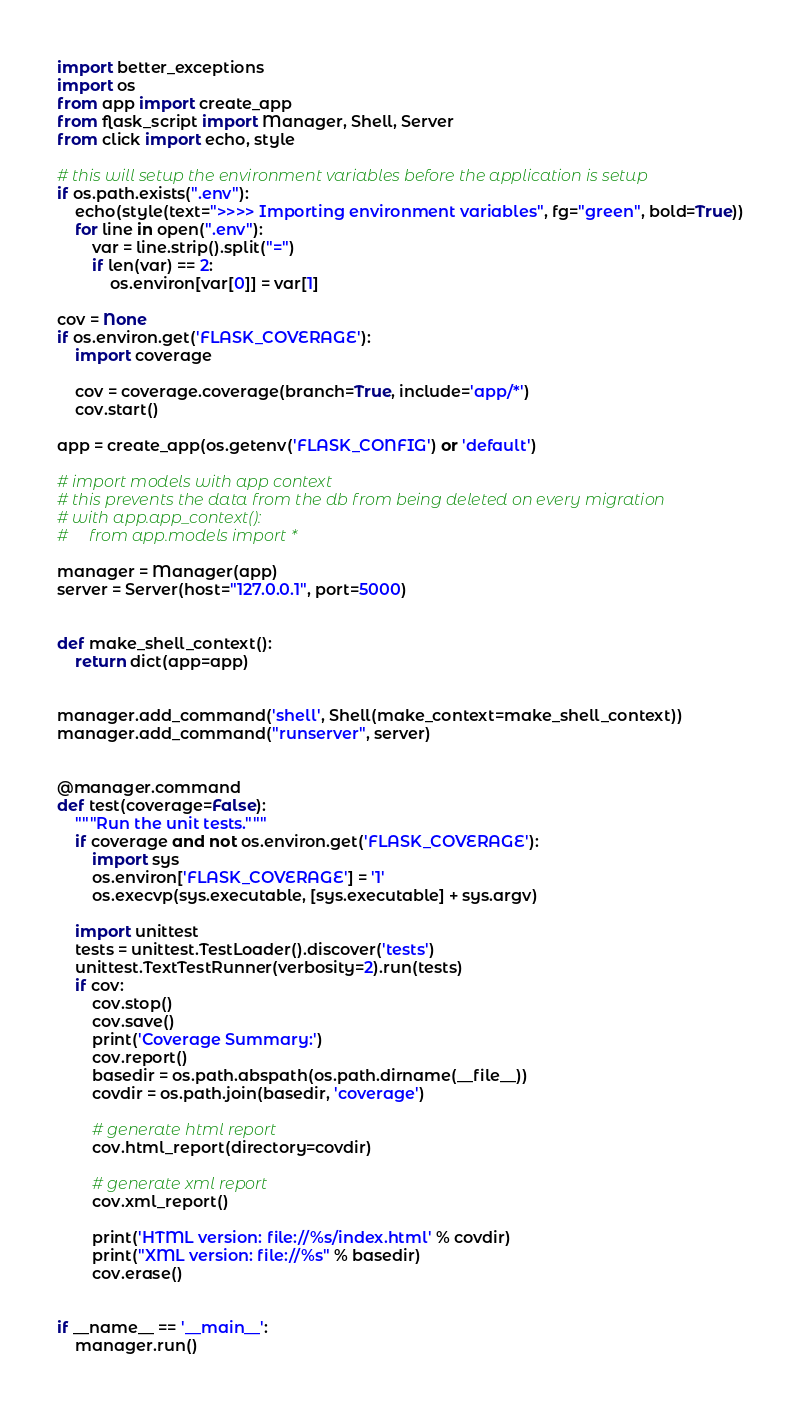<code> <loc_0><loc_0><loc_500><loc_500><_Python_>import better_exceptions
import os
from app import create_app
from flask_script import Manager, Shell, Server
from click import echo, style

# this will setup the environment variables before the application is setup
if os.path.exists(".env"):
    echo(style(text=">>>> Importing environment variables", fg="green", bold=True))
    for line in open(".env"):
        var = line.strip().split("=")
        if len(var) == 2:
            os.environ[var[0]] = var[1]

cov = None
if os.environ.get('FLASK_COVERAGE'):
    import coverage

    cov = coverage.coverage(branch=True, include='app/*')
    cov.start()

app = create_app(os.getenv('FLASK_CONFIG') or 'default')

# import models with app context
# this prevents the data from the db from being deleted on every migration
# with app.app_context():
#     from app.models import *

manager = Manager(app)
server = Server(host="127.0.0.1", port=5000)


def make_shell_context():
    return dict(app=app)


manager.add_command('shell', Shell(make_context=make_shell_context))
manager.add_command("runserver", server)


@manager.command
def test(coverage=False):
    """Run the unit tests."""
    if coverage and not os.environ.get('FLASK_COVERAGE'):
        import sys
        os.environ['FLASK_COVERAGE'] = '1'
        os.execvp(sys.executable, [sys.executable] + sys.argv)

    import unittest
    tests = unittest.TestLoader().discover('tests')
    unittest.TextTestRunner(verbosity=2).run(tests)
    if cov:
        cov.stop()
        cov.save()
        print('Coverage Summary:')
        cov.report()
        basedir = os.path.abspath(os.path.dirname(__file__))
        covdir = os.path.join(basedir, 'coverage')

        # generate html report
        cov.html_report(directory=covdir)

        # generate xml report
        cov.xml_report()

        print('HTML version: file://%s/index.html' % covdir)
        print("XML version: file://%s" % basedir)
        cov.erase()


if __name__ == '__main__':
    manager.run()
</code> 